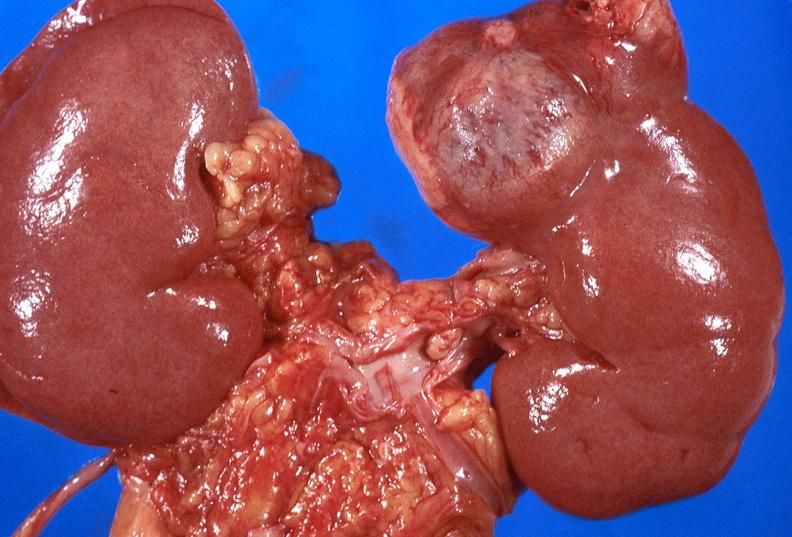does granulomata slide show renal cell carcinoma with extension into vena cava?
Answer the question using a single word or phrase. No 